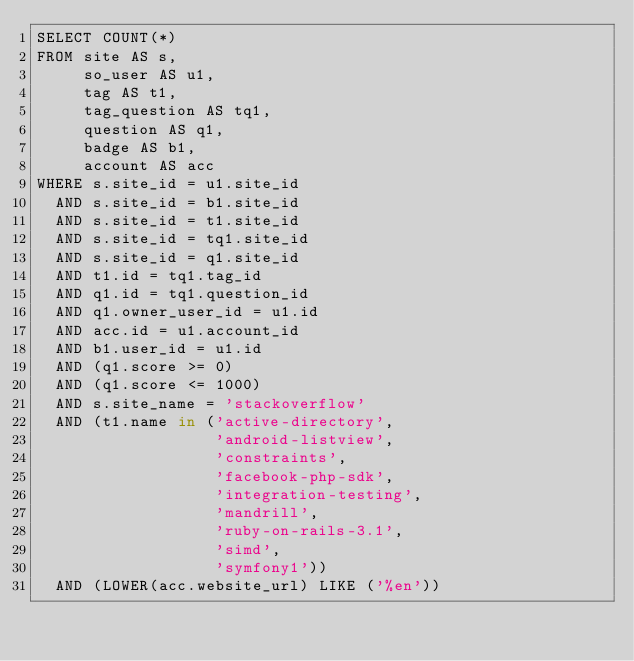<code> <loc_0><loc_0><loc_500><loc_500><_SQL_>SELECT COUNT(*)
FROM site AS s,
     so_user AS u1,
     tag AS t1,
     tag_question AS tq1,
     question AS q1,
     badge AS b1,
     account AS acc
WHERE s.site_id = u1.site_id
  AND s.site_id = b1.site_id
  AND s.site_id = t1.site_id
  AND s.site_id = tq1.site_id
  AND s.site_id = q1.site_id
  AND t1.id = tq1.tag_id
  AND q1.id = tq1.question_id
  AND q1.owner_user_id = u1.id
  AND acc.id = u1.account_id
  AND b1.user_id = u1.id
  AND (q1.score >= 0)
  AND (q1.score <= 1000)
  AND s.site_name = 'stackoverflow'
  AND (t1.name in ('active-directory',
                   'android-listview',
                   'constraints',
                   'facebook-php-sdk',
                   'integration-testing',
                   'mandrill',
                   'ruby-on-rails-3.1',
                   'simd',
                   'symfony1'))
  AND (LOWER(acc.website_url) LIKE ('%en'))</code> 